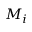<formula> <loc_0><loc_0><loc_500><loc_500>M _ { i }</formula> 